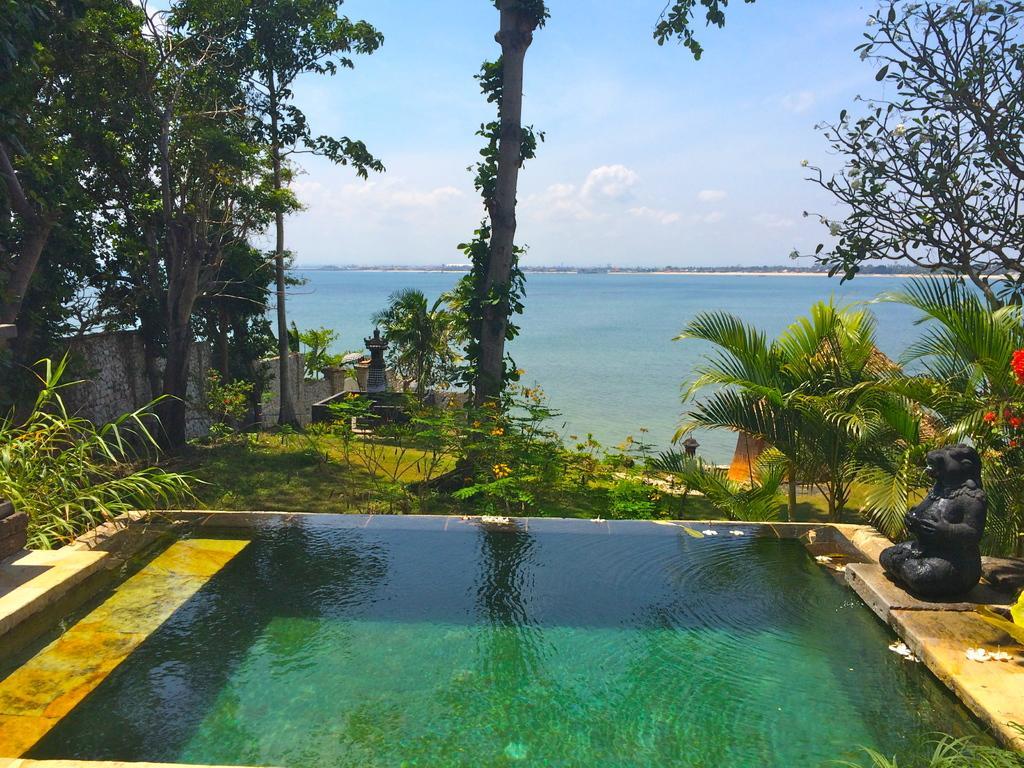Can you describe this image briefly? In this image there is a sculpture, flowers, swimming pool, plants, grass, water, trees,sky. 